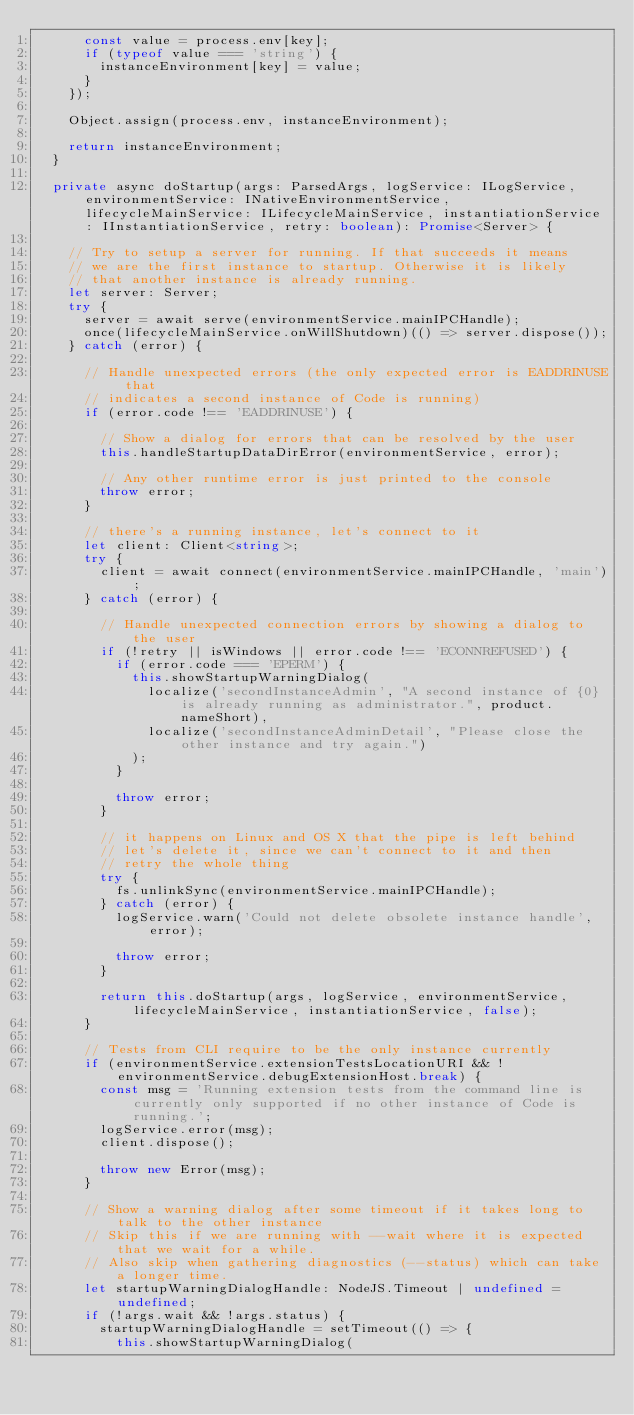Convert code to text. <code><loc_0><loc_0><loc_500><loc_500><_TypeScript_>			const value = process.env[key];
			if (typeof value === 'string') {
				instanceEnvironment[key] = value;
			}
		});

		Object.assign(process.env, instanceEnvironment);

		return instanceEnvironment;
	}

	private async doStartup(args: ParsedArgs, logService: ILogService, environmentService: INativeEnvironmentService, lifecycleMainService: ILifecycleMainService, instantiationService: IInstantiationService, retry: boolean): Promise<Server> {

		// Try to setup a server for running. If that succeeds it means
		// we are the first instance to startup. Otherwise it is likely
		// that another instance is already running.
		let server: Server;
		try {
			server = await serve(environmentService.mainIPCHandle);
			once(lifecycleMainService.onWillShutdown)(() => server.dispose());
		} catch (error) {

			// Handle unexpected errors (the only expected error is EADDRINUSE that
			// indicates a second instance of Code is running)
			if (error.code !== 'EADDRINUSE') {

				// Show a dialog for errors that can be resolved by the user
				this.handleStartupDataDirError(environmentService, error);

				// Any other runtime error is just printed to the console
				throw error;
			}

			// there's a running instance, let's connect to it
			let client: Client<string>;
			try {
				client = await connect(environmentService.mainIPCHandle, 'main');
			} catch (error) {

				// Handle unexpected connection errors by showing a dialog to the user
				if (!retry || isWindows || error.code !== 'ECONNREFUSED') {
					if (error.code === 'EPERM') {
						this.showStartupWarningDialog(
							localize('secondInstanceAdmin', "A second instance of {0} is already running as administrator.", product.nameShort),
							localize('secondInstanceAdminDetail', "Please close the other instance and try again.")
						);
					}

					throw error;
				}

				// it happens on Linux and OS X that the pipe is left behind
				// let's delete it, since we can't connect to it and then
				// retry the whole thing
				try {
					fs.unlinkSync(environmentService.mainIPCHandle);
				} catch (error) {
					logService.warn('Could not delete obsolete instance handle', error);

					throw error;
				}

				return this.doStartup(args, logService, environmentService, lifecycleMainService, instantiationService, false);
			}

			// Tests from CLI require to be the only instance currently
			if (environmentService.extensionTestsLocationURI && !environmentService.debugExtensionHost.break) {
				const msg = 'Running extension tests from the command line is currently only supported if no other instance of Code is running.';
				logService.error(msg);
				client.dispose();

				throw new Error(msg);
			}

			// Show a warning dialog after some timeout if it takes long to talk to the other instance
			// Skip this if we are running with --wait where it is expected that we wait for a while.
			// Also skip when gathering diagnostics (--status) which can take a longer time.
			let startupWarningDialogHandle: NodeJS.Timeout | undefined = undefined;
			if (!args.wait && !args.status) {
				startupWarningDialogHandle = setTimeout(() => {
					this.showStartupWarningDialog(</code> 